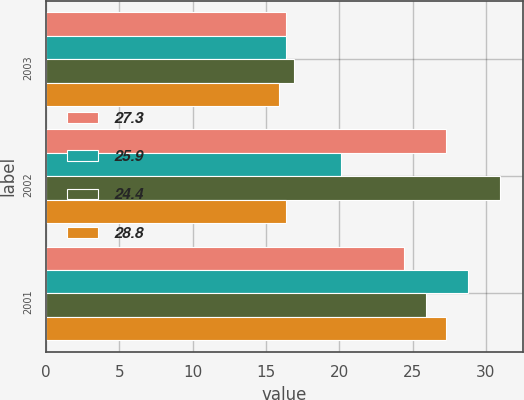Convert chart. <chart><loc_0><loc_0><loc_500><loc_500><stacked_bar_chart><ecel><fcel>2003<fcel>2002<fcel>2001<nl><fcel>27.3<fcel>16.4<fcel>27.3<fcel>24.4<nl><fcel>25.9<fcel>16.4<fcel>20.1<fcel>28.8<nl><fcel>24.4<fcel>16.9<fcel>31<fcel>25.9<nl><fcel>28.8<fcel>15.9<fcel>16.4<fcel>27.3<nl></chart> 